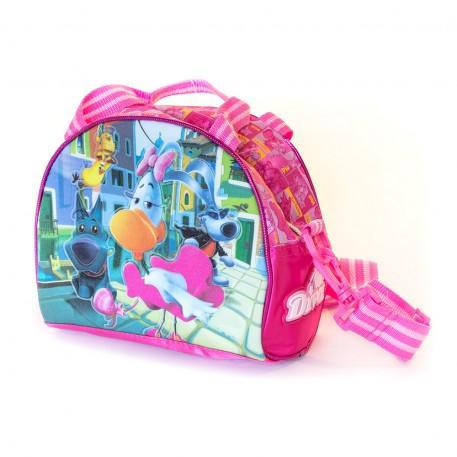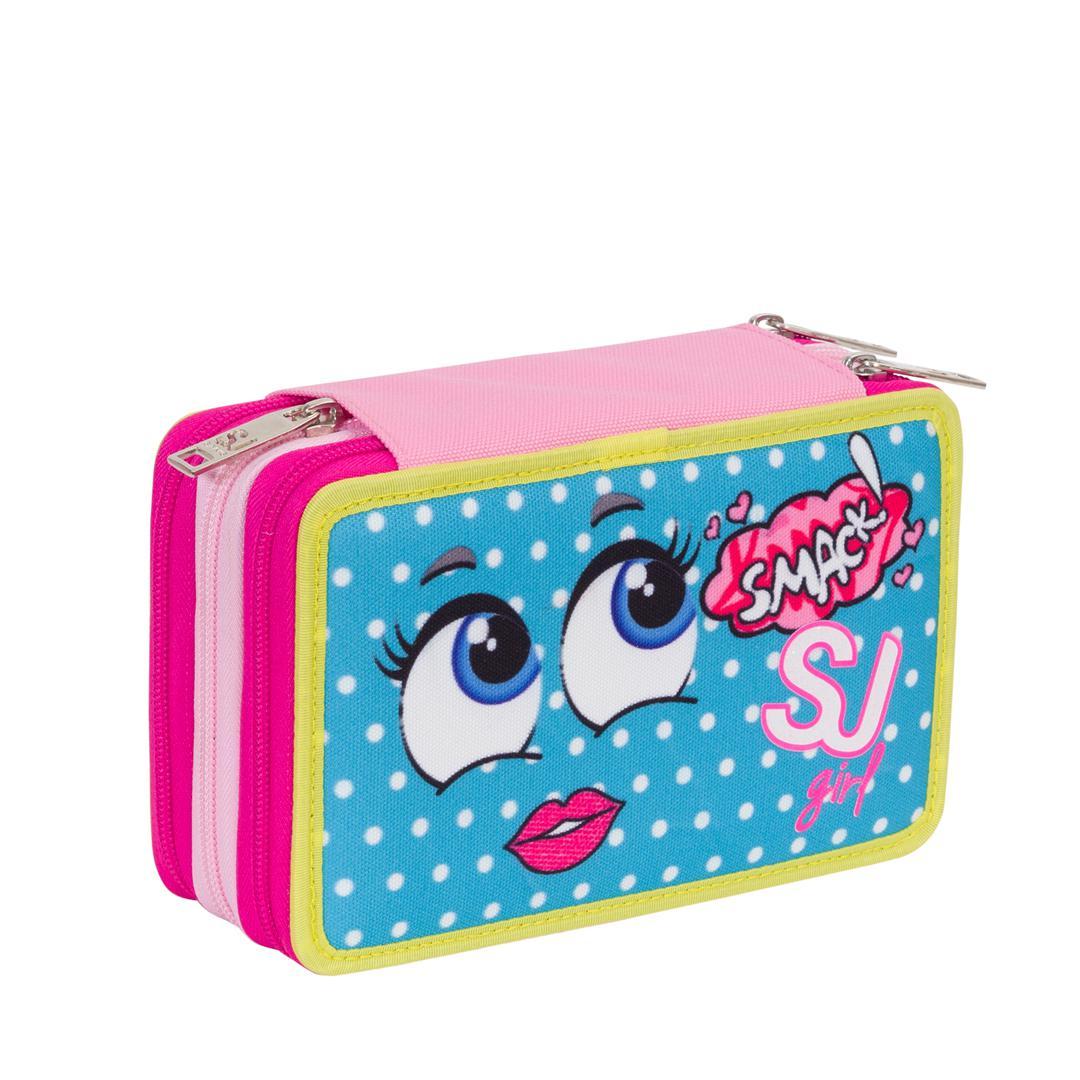The first image is the image on the left, the second image is the image on the right. For the images displayed, is the sentence "The case in one of the images is opened to reveal its contents." factually correct? Answer yes or no. No. The first image is the image on the left, the second image is the image on the right. Analyze the images presented: Is the assertion "There are writing utensils visible in one of the images." valid? Answer yes or no. No. 